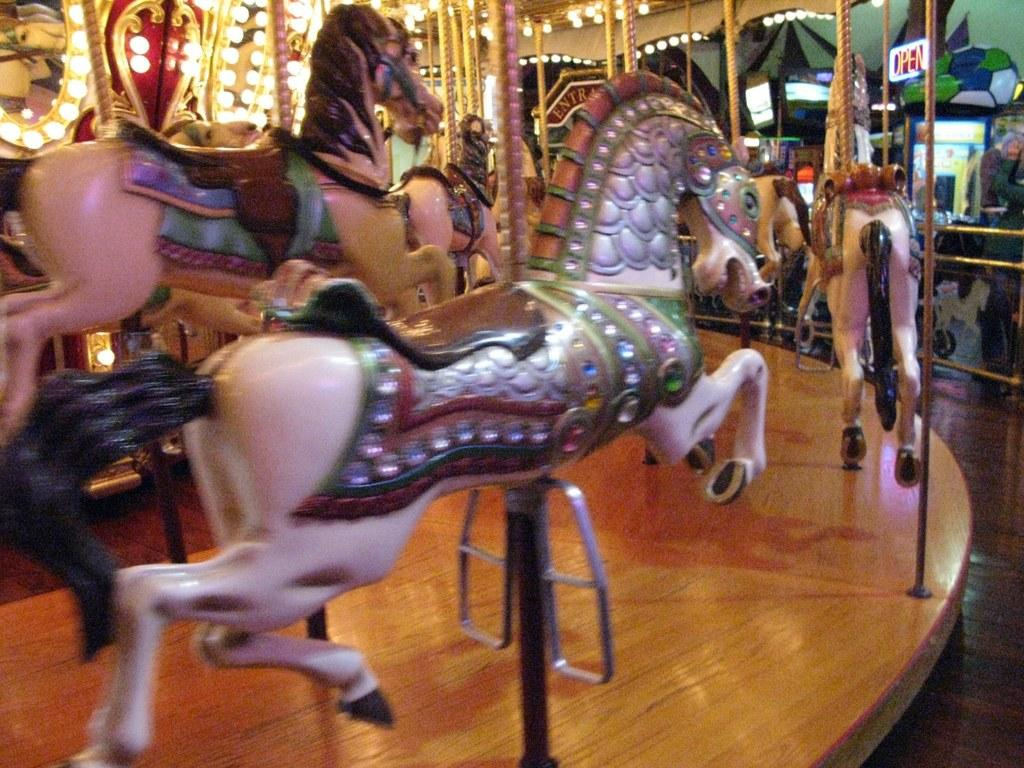What type of dolls are in the image? There are dolls in the shape of horses in the image. What can be seen on the left side of the image? There are lights on the left side of the image. What message is displayed on the digital board in the image? The digital board on the right side of the image has the text "Open" in red color. What type of education is being offered on the road in the image? There is no road or education present in the image; it features dolls in the shape of horses, lights, and a digital board with the text "Open." 